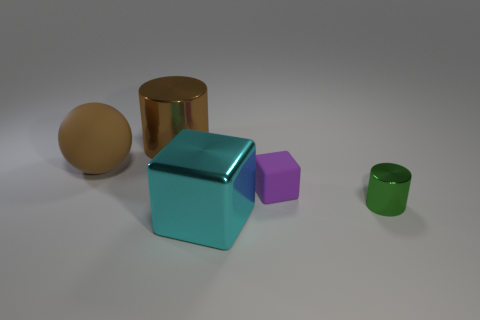Add 4 brown metallic things. How many objects exist? 9 Subtract all cylinders. How many objects are left? 3 Add 4 big yellow cylinders. How many big yellow cylinders exist? 4 Subtract 0 red cylinders. How many objects are left? 5 Subtract all cyan shiny objects. Subtract all tiny green metallic cylinders. How many objects are left? 3 Add 4 blocks. How many blocks are left? 6 